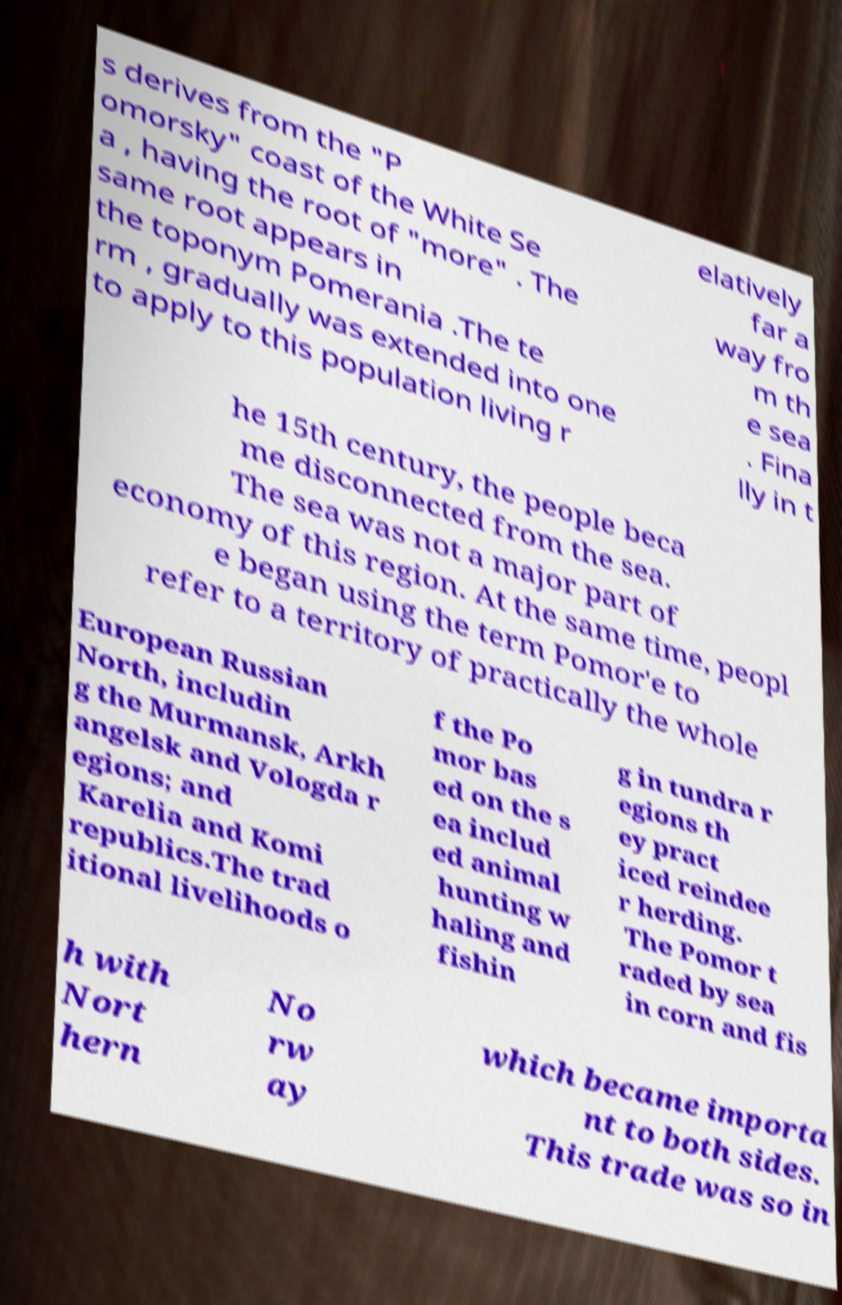What messages or text are displayed in this image? I need them in a readable, typed format. s derives from the "P omorsky" coast of the White Se a , having the root of "more" . The same root appears in the toponym Pomerania .The te rm , gradually was extended into one to apply to this population living r elatively far a way fro m th e sea . Fina lly in t he 15th century, the people beca me disconnected from the sea. The sea was not a major part of economy of this region. At the same time, peopl e began using the term Pomor'e to refer to a territory of practically the whole European Russian North, includin g the Murmansk, Arkh angelsk and Vologda r egions; and Karelia and Komi republics.The trad itional livelihoods o f the Po mor bas ed on the s ea includ ed animal hunting w haling and fishin g in tundra r egions th ey pract iced reindee r herding. The Pomor t raded by sea in corn and fis h with Nort hern No rw ay which became importa nt to both sides. This trade was so in 